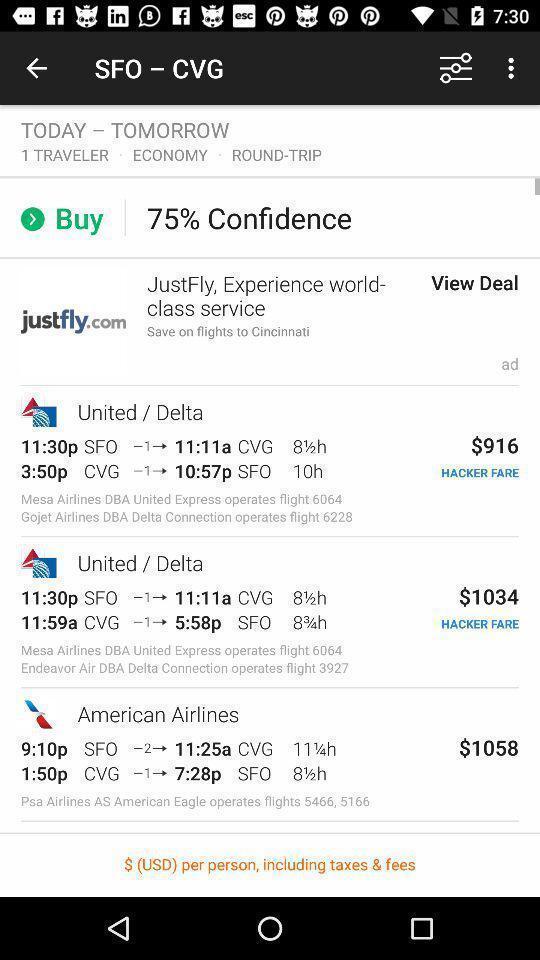Describe the key features of this screenshot. Screen displaying the list of airlines. 